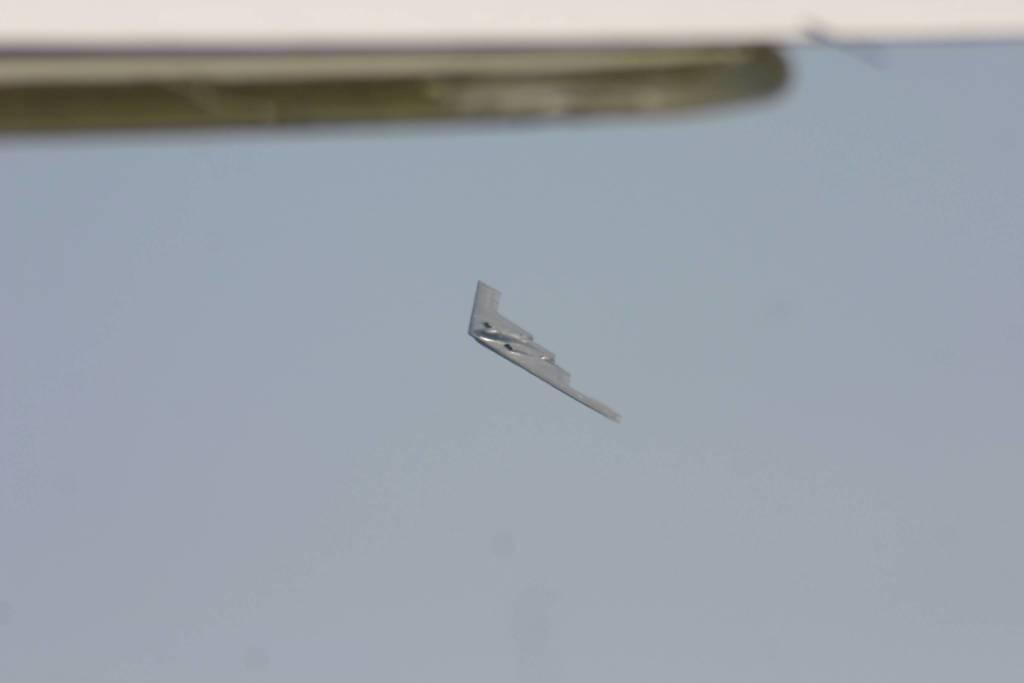What is the main subject in the middle of the image? There is an aircraft flying in the air in the middle of the image. What can be seen at the top of the image? There is an object at the top of the image. What is the color of the sky in the background of the image? The sky in the background of the image is blue with clouds. What type of egg is being used as a base for the aircraft in the image? There is no egg or base present in the image; it features an aircraft flying in the air. 